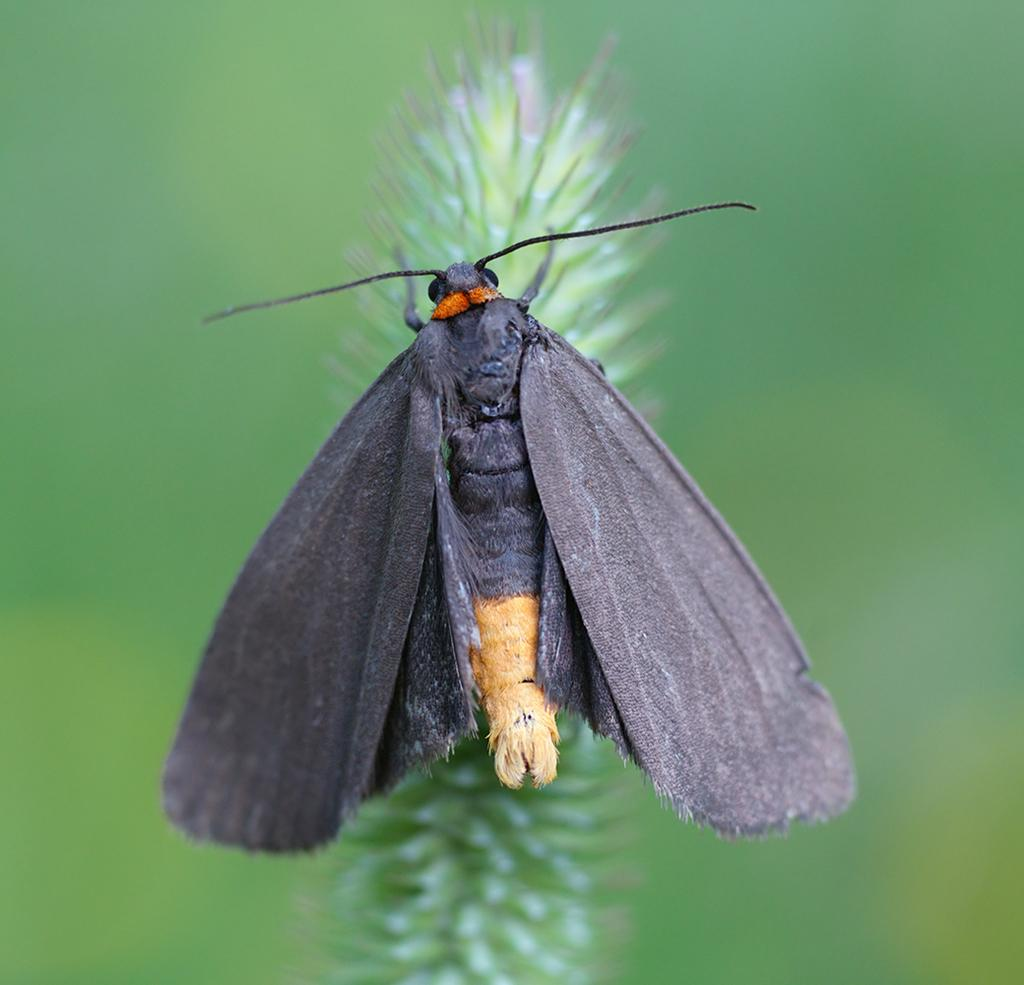What is the main subject of the image? There is a butterfly in the image. What color are the wings of the butterfly? The butterfly has gray color wings. Where is the butterfly located in the image? The butterfly is standing in the flowers of a plant. How would you describe the background of the image? The background of the image is blurred. What type of bucket can be seen in the image? There is no bucket present in the image; it features a butterfly standing in the flowers of a plant. How does the butterfly rub its wings together in the image? Butterflies do not rub their wings together; they flap their wings to fly. 